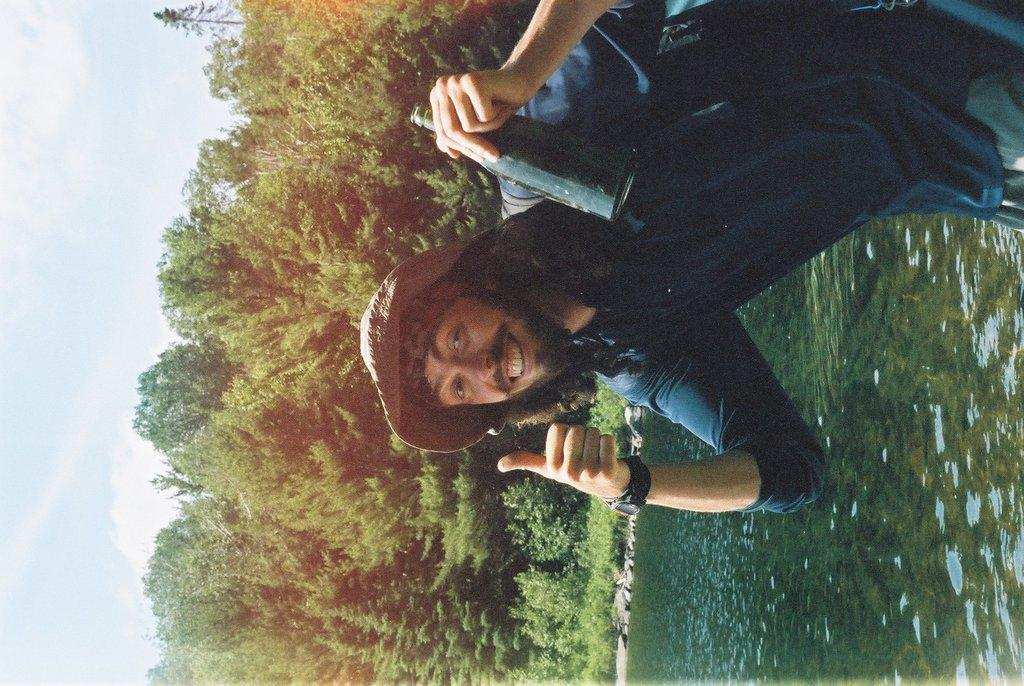Who is present in the image? There is a man in the image. What is the man holding in the image? The man is holding a bottle. What can be seen on the right side of the image? There is water on the right side of the image. What type of vegetation is in the middle of the image? There are trees in the middle of the image. What is visible on the left side of the image? The sky is visible on the left side of the image. What type of oil can be seen dripping from the trees in the image? There is no oil present in the image; it features a man holding a bottle, water on the right side, trees in the middle, and the sky on the left side. 